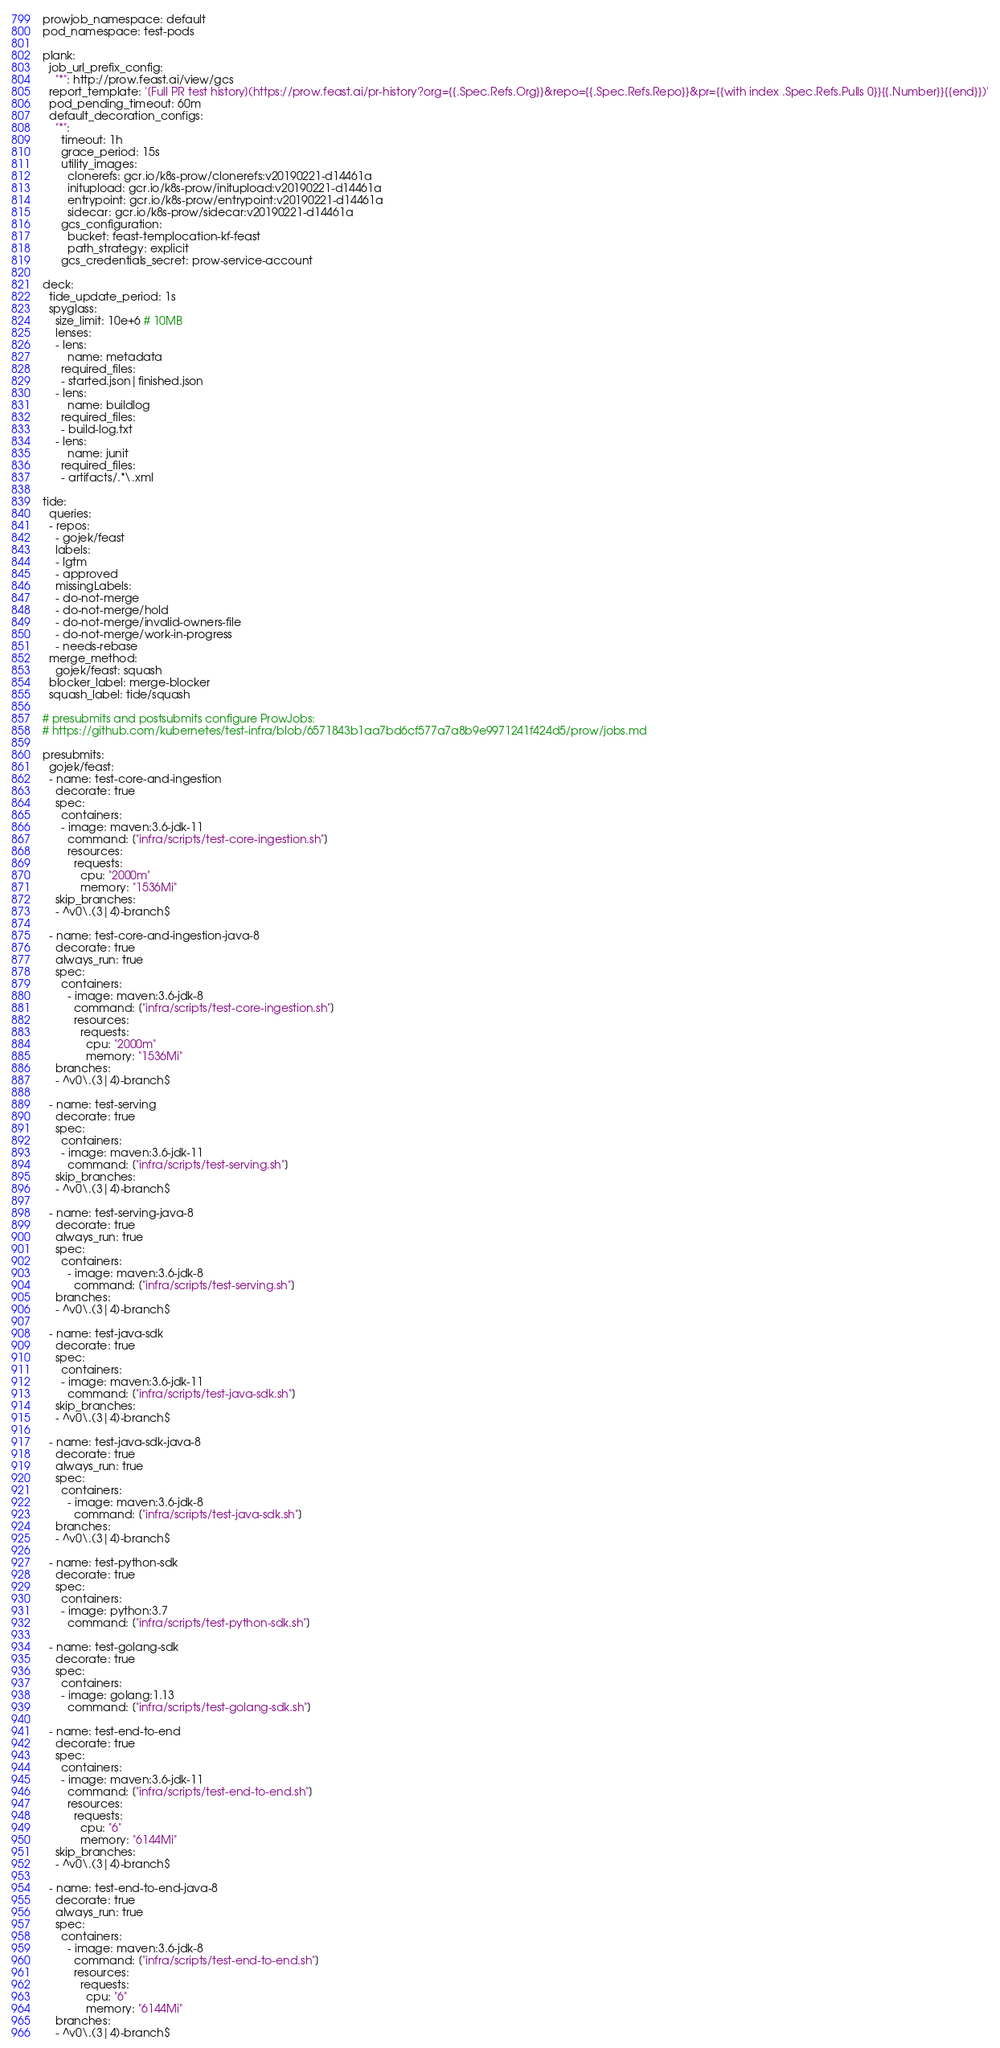Convert code to text. <code><loc_0><loc_0><loc_500><loc_500><_YAML_>prowjob_namespace: default
pod_namespace: test-pods

plank:
  job_url_prefix_config:
    "*": http://prow.feast.ai/view/gcs
  report_template: '[Full PR test history](https://prow.feast.ai/pr-history?org={{.Spec.Refs.Org}}&repo={{.Spec.Refs.Repo}}&pr={{with index .Spec.Refs.Pulls 0}}{{.Number}}{{end}})'
  pod_pending_timeout: 60m
  default_decoration_configs:
    "*":
      timeout: 1h
      grace_period: 15s
      utility_images:
        clonerefs: gcr.io/k8s-prow/clonerefs:v20190221-d14461a
        initupload: gcr.io/k8s-prow/initupload:v20190221-d14461a
        entrypoint: gcr.io/k8s-prow/entrypoint:v20190221-d14461a
        sidecar: gcr.io/k8s-prow/sidecar:v20190221-d14461a
      gcs_configuration:
        bucket: feast-templocation-kf-feast
        path_strategy: explicit
      gcs_credentials_secret: prow-service-account

deck:
  tide_update_period: 1s
  spyglass:
    size_limit: 10e+6 # 10MB
    lenses:
    - lens:
        name: metadata
      required_files:
      - started.json|finished.json
    - lens:
        name: buildlog
      required_files:
      - build-log.txt
    - lens:
        name: junit
      required_files:
      - artifacts/.*\.xml

tide:
  queries:
  - repos:
    - gojek/feast
    labels:
    - lgtm
    - approved
    missingLabels:
    - do-not-merge
    - do-not-merge/hold
    - do-not-merge/invalid-owners-file
    - do-not-merge/work-in-progress
    - needs-rebase
  merge_method:
    gojek/feast: squash
  blocker_label: merge-blocker
  squash_label: tide/squash

# presubmits and postsubmits configure ProwJobs:
# https://github.com/kubernetes/test-infra/blob/6571843b1aa7bd6cf577a7a8b9e9971241f424d5/prow/jobs.md

presubmits:
  gojek/feast:
  - name: test-core-and-ingestion
    decorate: true
    spec:
      containers:
      - image: maven:3.6-jdk-11
        command: ["infra/scripts/test-core-ingestion.sh"]
        resources:
          requests:
            cpu: "2000m"
            memory: "1536Mi"
    skip_branches:
    - ^v0\.(3|4)-branch$

  - name: test-core-and-ingestion-java-8
    decorate: true
    always_run: true
    spec:
      containers:
        - image: maven:3.6-jdk-8
          command: ["infra/scripts/test-core-ingestion.sh"]
          resources:
            requests:
              cpu: "2000m"
              memory: "1536Mi"
    branches:
    - ^v0\.(3|4)-branch$

  - name: test-serving
    decorate: true
    spec:
      containers:
      - image: maven:3.6-jdk-11
        command: ["infra/scripts/test-serving.sh"]
    skip_branches:
    - ^v0\.(3|4)-branch$

  - name: test-serving-java-8
    decorate: true
    always_run: true
    spec:
      containers:
        - image: maven:3.6-jdk-8
          command: ["infra/scripts/test-serving.sh"]
    branches:
    - ^v0\.(3|4)-branch$

  - name: test-java-sdk
    decorate: true
    spec:
      containers:
      - image: maven:3.6-jdk-11
        command: ["infra/scripts/test-java-sdk.sh"]
    skip_branches:
    - ^v0\.(3|4)-branch$

  - name: test-java-sdk-java-8
    decorate: true
    always_run: true
    spec:
      containers:
        - image: maven:3.6-jdk-8
          command: ["infra/scripts/test-java-sdk.sh"]
    branches:
    - ^v0\.(3|4)-branch$

  - name: test-python-sdk
    decorate: true
    spec:
      containers:
      - image: python:3.7
        command: ["infra/scripts/test-python-sdk.sh"]

  - name: test-golang-sdk
    decorate: true
    spec:
      containers:
      - image: golang:1.13
        command: ["infra/scripts/test-golang-sdk.sh"]

  - name: test-end-to-end
    decorate: true
    spec:
      containers:
      - image: maven:3.6-jdk-11
        command: ["infra/scripts/test-end-to-end.sh"]
        resources:
          requests:
            cpu: "6"
            memory: "6144Mi"
    skip_branches:
    - ^v0\.(3|4)-branch$

  - name: test-end-to-end-java-8
    decorate: true
    always_run: true
    spec:
      containers:
        - image: maven:3.6-jdk-8
          command: ["infra/scripts/test-end-to-end.sh"]
          resources:
            requests:
              cpu: "6"
              memory: "6144Mi"
    branches:
    - ^v0\.(3|4)-branch$
</code> 